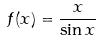<formula> <loc_0><loc_0><loc_500><loc_500>f ( x ) = \frac { x } { \sin x }</formula> 